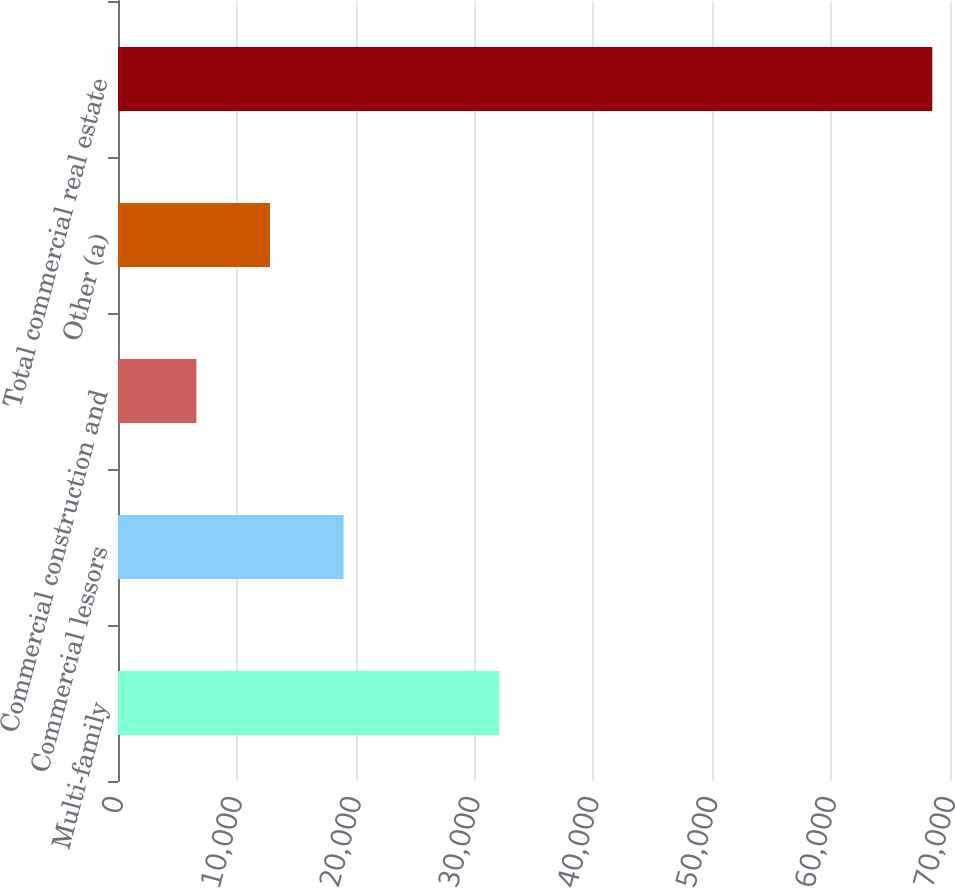Convert chart to OTSL. <chart><loc_0><loc_0><loc_500><loc_500><bar_chart><fcel>Multi-family<fcel>Commercial lessors<fcel>Commercial construction and<fcel>Other (a)<fcel>Total commercial real estate<nl><fcel>32073<fcel>18976.2<fcel>6593<fcel>12784.6<fcel>68509<nl></chart> 